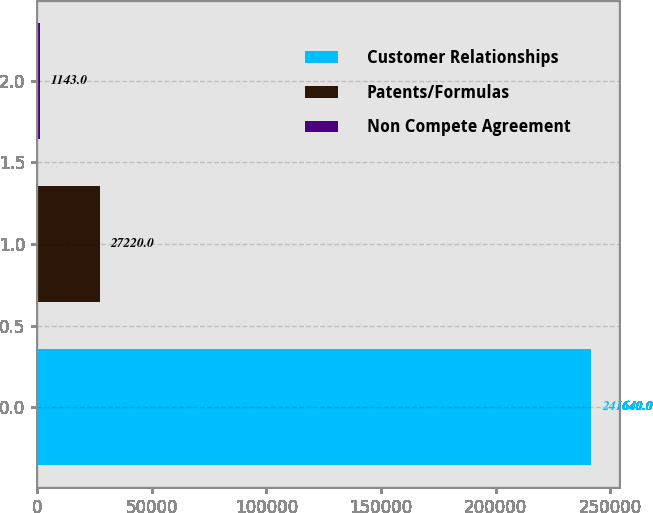<chart> <loc_0><loc_0><loc_500><loc_500><bar_chart><fcel>Customer Relationships<fcel>Patents/Formulas<fcel>Non Compete Agreement<nl><fcel>241640<fcel>27220<fcel>1143<nl></chart> 